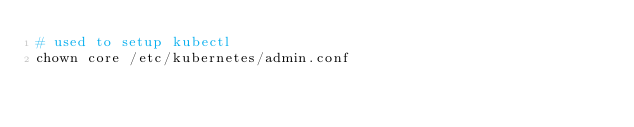<code> <loc_0><loc_0><loc_500><loc_500><_Bash_># used to setup kubectl 
chown core /etc/kubernetes/admin.conf
</code> 